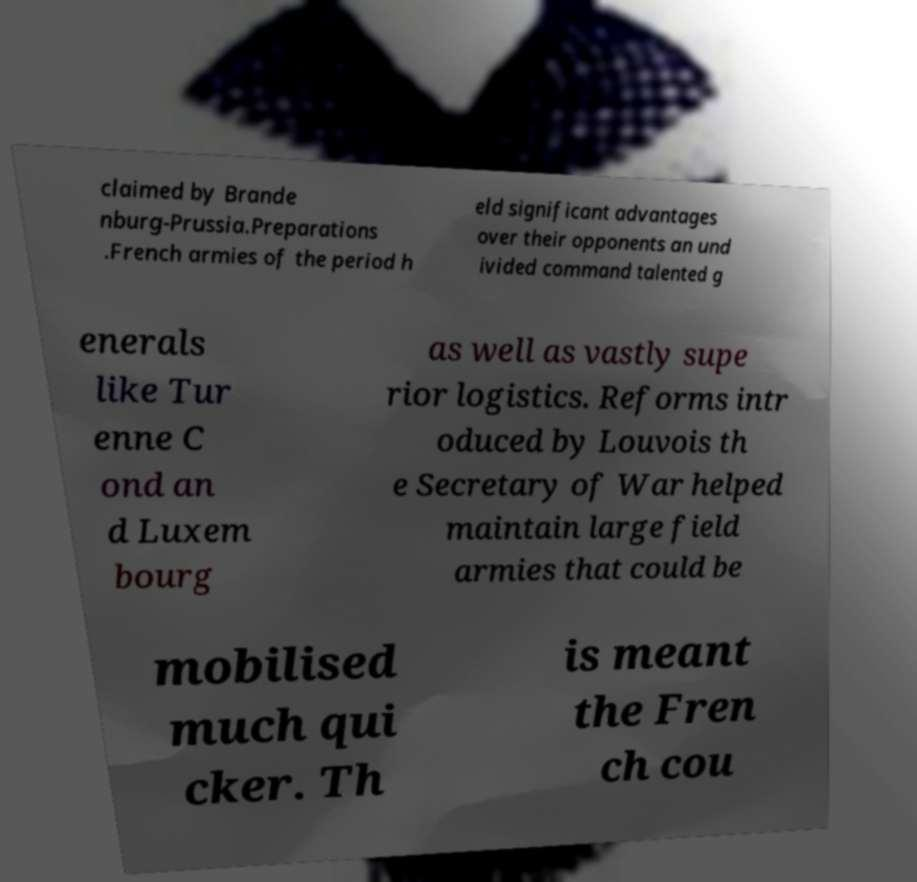Could you extract and type out the text from this image? claimed by Brande nburg-Prussia.Preparations .French armies of the period h eld significant advantages over their opponents an und ivided command talented g enerals like Tur enne C ond an d Luxem bourg as well as vastly supe rior logistics. Reforms intr oduced by Louvois th e Secretary of War helped maintain large field armies that could be mobilised much qui cker. Th is meant the Fren ch cou 